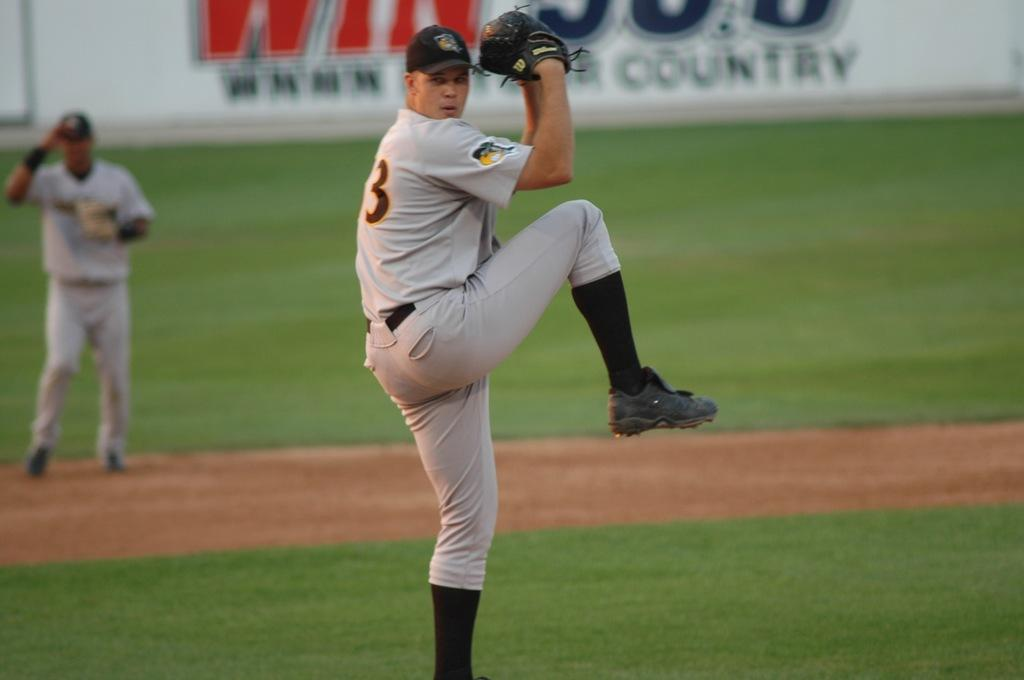<image>
Describe the image concisely. A baseball player winds up to throw a baseball with a country billboard in the background. 